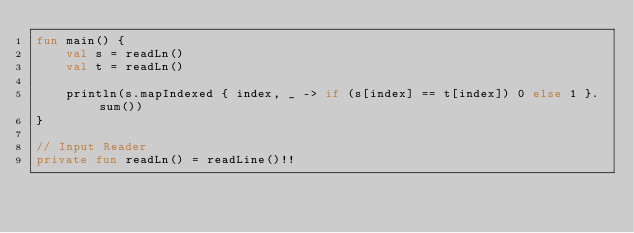Convert code to text. <code><loc_0><loc_0><loc_500><loc_500><_Kotlin_>fun main() {
    val s = readLn()
    val t = readLn()

    println(s.mapIndexed { index, _ -> if (s[index] == t[index]) 0 else 1 }.sum())
}

// Input Reader
private fun readLn() = readLine()!!
</code> 